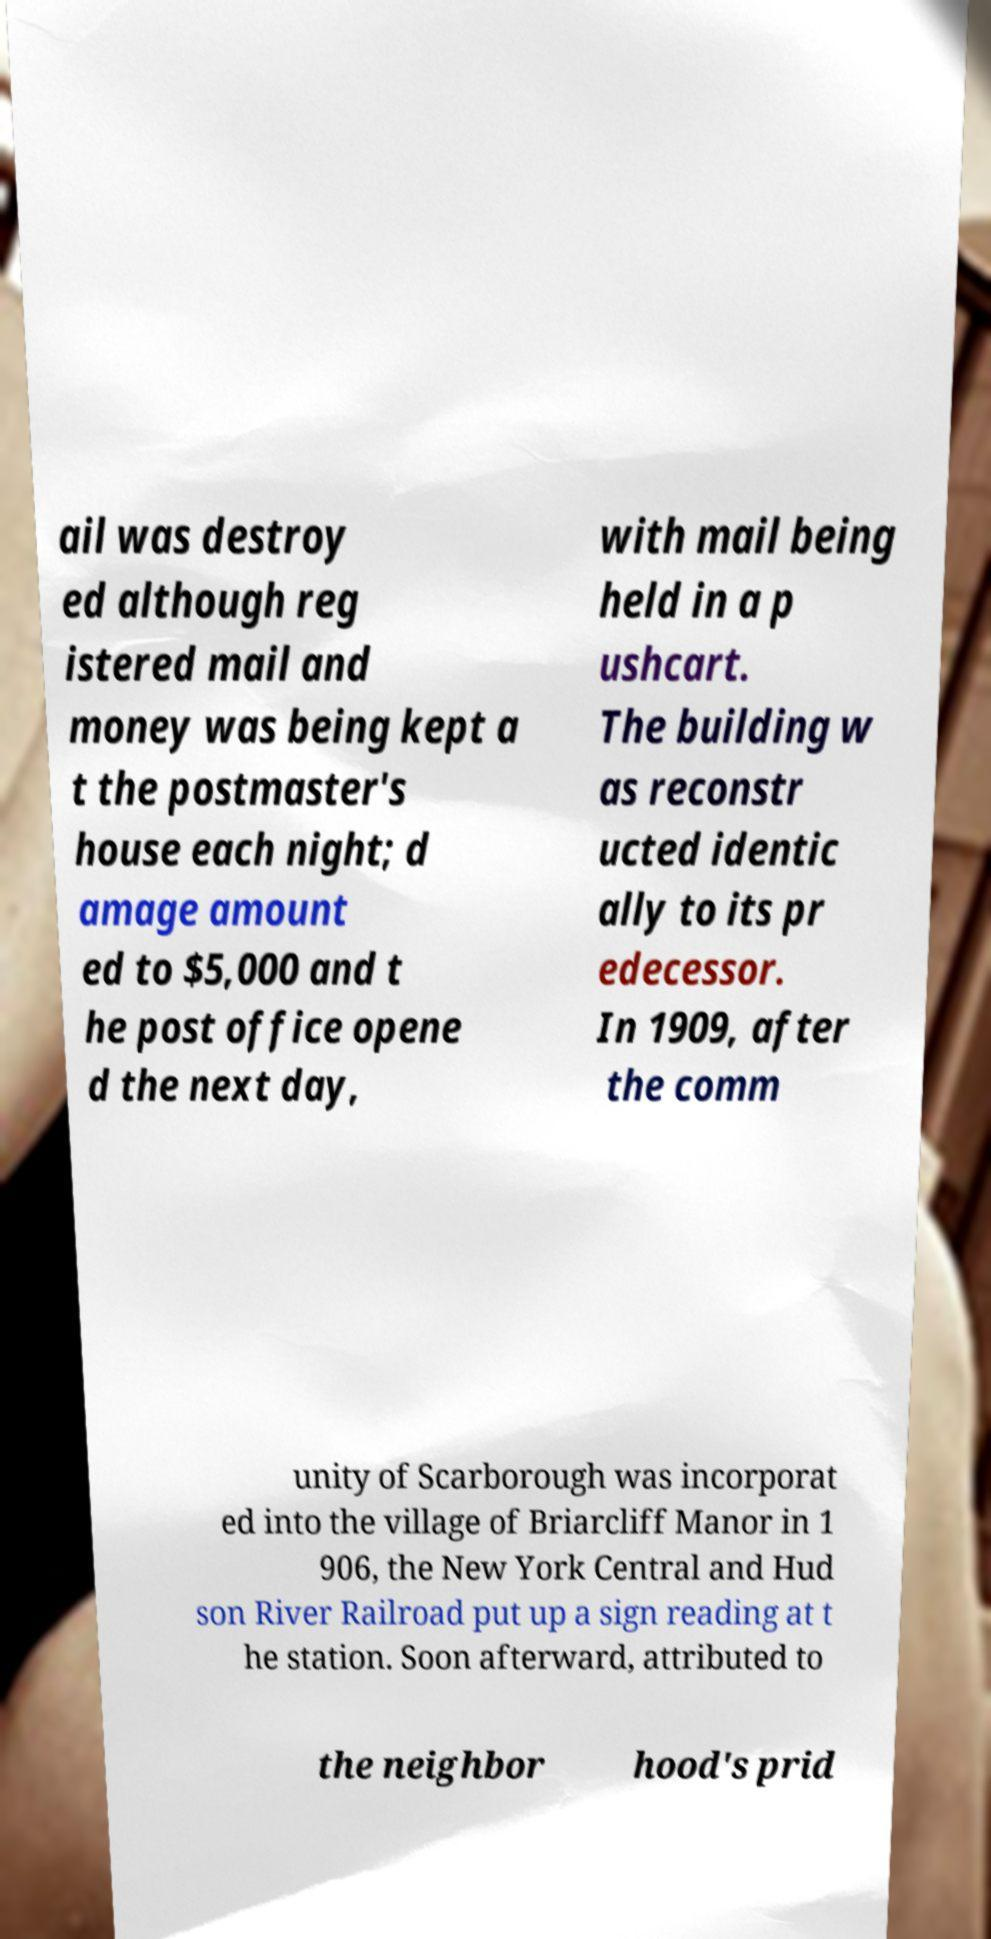There's text embedded in this image that I need extracted. Can you transcribe it verbatim? ail was destroy ed although reg istered mail and money was being kept a t the postmaster's house each night; d amage amount ed to $5,000 and t he post office opene d the next day, with mail being held in a p ushcart. The building w as reconstr ucted identic ally to its pr edecessor. In 1909, after the comm unity of Scarborough was incorporat ed into the village of Briarcliff Manor in 1 906, the New York Central and Hud son River Railroad put up a sign reading at t he station. Soon afterward, attributed to the neighbor hood's prid 